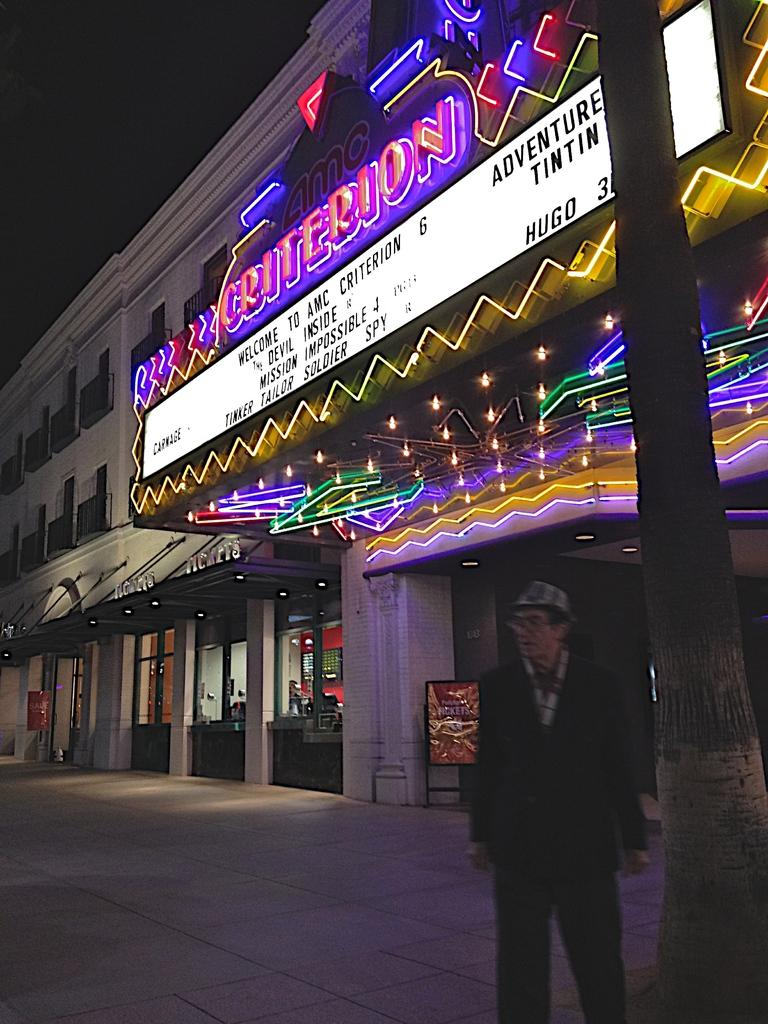Who is present on the right side of the image? There is a man standing on the right side of the image. What type of structures can be seen in the image? There are buildings in the image. What object is visible in the image that might have information or instructions? There is a board visible in the image. What type of illumination is present in the image? There are lights in the image. What is visible at the top of the image? The sky is visible at the top of the image. How much cloth is draped over the man's shoulders in the image? There is no cloth draped over the man's shoulders in the image. What type of flight is taking place in the image? There is no flight present in the image; it features a man, buildings, a board, lights, and the sky. 